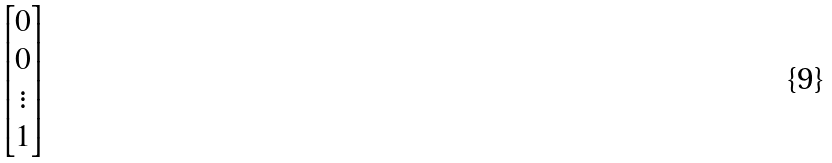Convert formula to latex. <formula><loc_0><loc_0><loc_500><loc_500>\begin{bmatrix} 0 \\ 0 \\ \vdots \\ 1 \end{bmatrix}</formula> 